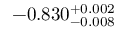Convert formula to latex. <formula><loc_0><loc_0><loc_500><loc_500>- 0 . 8 3 0 _ { - 0 . 0 0 8 } ^ { + 0 . 0 0 2 }</formula> 